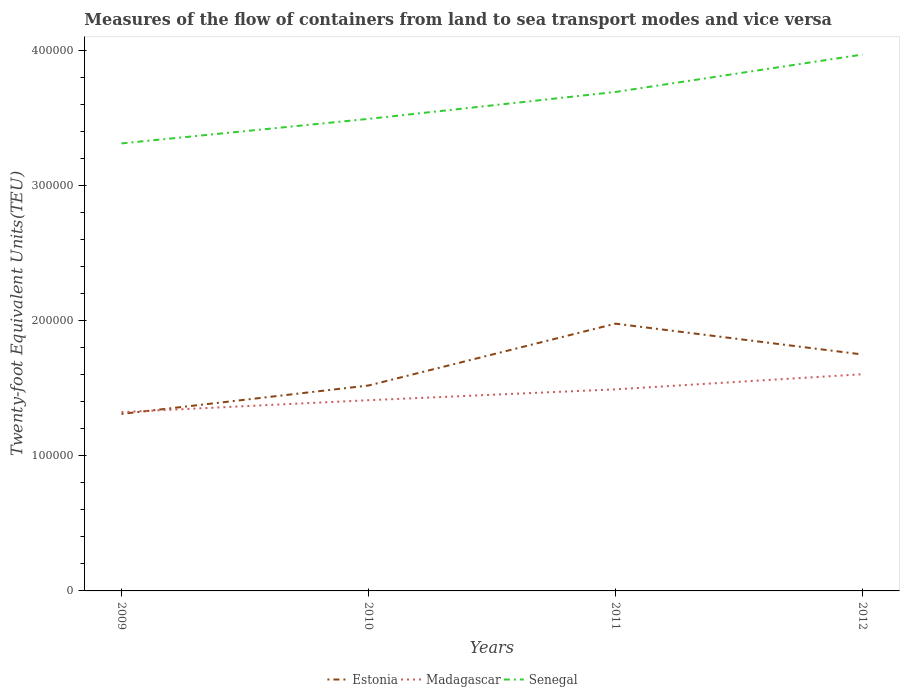Does the line corresponding to Estonia intersect with the line corresponding to Senegal?
Offer a terse response. No. Is the number of lines equal to the number of legend labels?
Provide a short and direct response. Yes. Across all years, what is the maximum container port traffic in Estonia?
Your answer should be compact. 1.31e+05. In which year was the container port traffic in Madagascar maximum?
Your response must be concise. 2009. What is the total container port traffic in Senegal in the graph?
Offer a very short reply. -1.99e+04. What is the difference between the highest and the second highest container port traffic in Madagascar?
Offer a very short reply. 2.80e+04. Is the container port traffic in Madagascar strictly greater than the container port traffic in Estonia over the years?
Offer a very short reply. No. How many years are there in the graph?
Your response must be concise. 4. What is the title of the graph?
Keep it short and to the point. Measures of the flow of containers from land to sea transport modes and vice versa. What is the label or title of the X-axis?
Your answer should be very brief. Years. What is the label or title of the Y-axis?
Give a very brief answer. Twenty-foot Equivalent Units(TEU). What is the Twenty-foot Equivalent Units(TEU) in Estonia in 2009?
Your response must be concise. 1.31e+05. What is the Twenty-foot Equivalent Units(TEU) of Madagascar in 2009?
Give a very brief answer. 1.32e+05. What is the Twenty-foot Equivalent Units(TEU) of Senegal in 2009?
Offer a very short reply. 3.31e+05. What is the Twenty-foot Equivalent Units(TEU) in Estonia in 2010?
Provide a succinct answer. 1.52e+05. What is the Twenty-foot Equivalent Units(TEU) in Madagascar in 2010?
Offer a terse response. 1.41e+05. What is the Twenty-foot Equivalent Units(TEU) in Senegal in 2010?
Give a very brief answer. 3.49e+05. What is the Twenty-foot Equivalent Units(TEU) of Estonia in 2011?
Offer a very short reply. 1.98e+05. What is the Twenty-foot Equivalent Units(TEU) in Madagascar in 2011?
Keep it short and to the point. 1.49e+05. What is the Twenty-foot Equivalent Units(TEU) in Senegal in 2011?
Ensure brevity in your answer.  3.69e+05. What is the Twenty-foot Equivalent Units(TEU) of Estonia in 2012?
Make the answer very short. 1.75e+05. What is the Twenty-foot Equivalent Units(TEU) in Madagascar in 2012?
Offer a terse response. 1.60e+05. What is the Twenty-foot Equivalent Units(TEU) of Senegal in 2012?
Your answer should be very brief. 3.97e+05. Across all years, what is the maximum Twenty-foot Equivalent Units(TEU) of Estonia?
Ensure brevity in your answer.  1.98e+05. Across all years, what is the maximum Twenty-foot Equivalent Units(TEU) in Madagascar?
Your response must be concise. 1.60e+05. Across all years, what is the maximum Twenty-foot Equivalent Units(TEU) in Senegal?
Offer a terse response. 3.97e+05. Across all years, what is the minimum Twenty-foot Equivalent Units(TEU) of Estonia?
Offer a terse response. 1.31e+05. Across all years, what is the minimum Twenty-foot Equivalent Units(TEU) in Madagascar?
Offer a terse response. 1.32e+05. Across all years, what is the minimum Twenty-foot Equivalent Units(TEU) of Senegal?
Provide a short and direct response. 3.31e+05. What is the total Twenty-foot Equivalent Units(TEU) of Estonia in the graph?
Offer a terse response. 6.56e+05. What is the total Twenty-foot Equivalent Units(TEU) of Madagascar in the graph?
Provide a short and direct response. 5.83e+05. What is the total Twenty-foot Equivalent Units(TEU) in Senegal in the graph?
Provide a short and direct response. 1.45e+06. What is the difference between the Twenty-foot Equivalent Units(TEU) in Estonia in 2009 and that in 2010?
Make the answer very short. -2.10e+04. What is the difference between the Twenty-foot Equivalent Units(TEU) in Madagascar in 2009 and that in 2010?
Ensure brevity in your answer.  -8815. What is the difference between the Twenty-foot Equivalent Units(TEU) in Senegal in 2009 and that in 2010?
Give a very brief answer. -1.82e+04. What is the difference between the Twenty-foot Equivalent Units(TEU) of Estonia in 2009 and that in 2011?
Offer a terse response. -6.68e+04. What is the difference between the Twenty-foot Equivalent Units(TEU) of Madagascar in 2009 and that in 2011?
Your answer should be very brief. -1.69e+04. What is the difference between the Twenty-foot Equivalent Units(TEU) of Senegal in 2009 and that in 2011?
Make the answer very short. -3.81e+04. What is the difference between the Twenty-foot Equivalent Units(TEU) of Estonia in 2009 and that in 2012?
Make the answer very short. -4.40e+04. What is the difference between the Twenty-foot Equivalent Units(TEU) in Madagascar in 2009 and that in 2012?
Your answer should be compact. -2.80e+04. What is the difference between the Twenty-foot Equivalent Units(TEU) of Senegal in 2009 and that in 2012?
Offer a terse response. -6.57e+04. What is the difference between the Twenty-foot Equivalent Units(TEU) of Estonia in 2010 and that in 2011?
Give a very brief answer. -4.57e+04. What is the difference between the Twenty-foot Equivalent Units(TEU) in Madagascar in 2010 and that in 2011?
Provide a short and direct response. -8042.3. What is the difference between the Twenty-foot Equivalent Units(TEU) of Senegal in 2010 and that in 2011?
Keep it short and to the point. -1.99e+04. What is the difference between the Twenty-foot Equivalent Units(TEU) of Estonia in 2010 and that in 2012?
Keep it short and to the point. -2.30e+04. What is the difference between the Twenty-foot Equivalent Units(TEU) in Madagascar in 2010 and that in 2012?
Ensure brevity in your answer.  -1.92e+04. What is the difference between the Twenty-foot Equivalent Units(TEU) in Senegal in 2010 and that in 2012?
Your answer should be very brief. -4.76e+04. What is the difference between the Twenty-foot Equivalent Units(TEU) of Estonia in 2011 and that in 2012?
Your response must be concise. 2.28e+04. What is the difference between the Twenty-foot Equivalent Units(TEU) of Madagascar in 2011 and that in 2012?
Provide a short and direct response. -1.12e+04. What is the difference between the Twenty-foot Equivalent Units(TEU) of Senegal in 2011 and that in 2012?
Make the answer very short. -2.77e+04. What is the difference between the Twenty-foot Equivalent Units(TEU) of Estonia in 2009 and the Twenty-foot Equivalent Units(TEU) of Madagascar in 2010?
Offer a very short reply. -1.02e+04. What is the difference between the Twenty-foot Equivalent Units(TEU) in Estonia in 2009 and the Twenty-foot Equivalent Units(TEU) in Senegal in 2010?
Give a very brief answer. -2.18e+05. What is the difference between the Twenty-foot Equivalent Units(TEU) of Madagascar in 2009 and the Twenty-foot Equivalent Units(TEU) of Senegal in 2010?
Make the answer very short. -2.17e+05. What is the difference between the Twenty-foot Equivalent Units(TEU) of Estonia in 2009 and the Twenty-foot Equivalent Units(TEU) of Madagascar in 2011?
Ensure brevity in your answer.  -1.82e+04. What is the difference between the Twenty-foot Equivalent Units(TEU) in Estonia in 2009 and the Twenty-foot Equivalent Units(TEU) in Senegal in 2011?
Provide a succinct answer. -2.38e+05. What is the difference between the Twenty-foot Equivalent Units(TEU) of Madagascar in 2009 and the Twenty-foot Equivalent Units(TEU) of Senegal in 2011?
Your answer should be compact. -2.37e+05. What is the difference between the Twenty-foot Equivalent Units(TEU) of Estonia in 2009 and the Twenty-foot Equivalent Units(TEU) of Madagascar in 2012?
Your answer should be compact. -2.94e+04. What is the difference between the Twenty-foot Equivalent Units(TEU) in Estonia in 2009 and the Twenty-foot Equivalent Units(TEU) in Senegal in 2012?
Offer a very short reply. -2.66e+05. What is the difference between the Twenty-foot Equivalent Units(TEU) of Madagascar in 2009 and the Twenty-foot Equivalent Units(TEU) of Senegal in 2012?
Offer a terse response. -2.65e+05. What is the difference between the Twenty-foot Equivalent Units(TEU) of Estonia in 2010 and the Twenty-foot Equivalent Units(TEU) of Madagascar in 2011?
Make the answer very short. 2833.7. What is the difference between the Twenty-foot Equivalent Units(TEU) of Estonia in 2010 and the Twenty-foot Equivalent Units(TEU) of Senegal in 2011?
Make the answer very short. -2.17e+05. What is the difference between the Twenty-foot Equivalent Units(TEU) of Madagascar in 2010 and the Twenty-foot Equivalent Units(TEU) of Senegal in 2011?
Make the answer very short. -2.28e+05. What is the difference between the Twenty-foot Equivalent Units(TEU) in Estonia in 2010 and the Twenty-foot Equivalent Units(TEU) in Madagascar in 2012?
Provide a short and direct response. -8351.45. What is the difference between the Twenty-foot Equivalent Units(TEU) of Estonia in 2010 and the Twenty-foot Equivalent Units(TEU) of Senegal in 2012?
Offer a very short reply. -2.45e+05. What is the difference between the Twenty-foot Equivalent Units(TEU) of Madagascar in 2010 and the Twenty-foot Equivalent Units(TEU) of Senegal in 2012?
Ensure brevity in your answer.  -2.56e+05. What is the difference between the Twenty-foot Equivalent Units(TEU) of Estonia in 2011 and the Twenty-foot Equivalent Units(TEU) of Madagascar in 2012?
Provide a succinct answer. 3.74e+04. What is the difference between the Twenty-foot Equivalent Units(TEU) in Estonia in 2011 and the Twenty-foot Equivalent Units(TEU) in Senegal in 2012?
Your answer should be very brief. -1.99e+05. What is the difference between the Twenty-foot Equivalent Units(TEU) of Madagascar in 2011 and the Twenty-foot Equivalent Units(TEU) of Senegal in 2012?
Give a very brief answer. -2.48e+05. What is the average Twenty-foot Equivalent Units(TEU) in Estonia per year?
Offer a very short reply. 1.64e+05. What is the average Twenty-foot Equivalent Units(TEU) in Madagascar per year?
Your answer should be very brief. 1.46e+05. What is the average Twenty-foot Equivalent Units(TEU) of Senegal per year?
Give a very brief answer. 3.62e+05. In the year 2009, what is the difference between the Twenty-foot Equivalent Units(TEU) of Estonia and Twenty-foot Equivalent Units(TEU) of Madagascar?
Give a very brief answer. -1339. In the year 2009, what is the difference between the Twenty-foot Equivalent Units(TEU) of Estonia and Twenty-foot Equivalent Units(TEU) of Senegal?
Provide a short and direct response. -2.00e+05. In the year 2009, what is the difference between the Twenty-foot Equivalent Units(TEU) in Madagascar and Twenty-foot Equivalent Units(TEU) in Senegal?
Your answer should be compact. -1.99e+05. In the year 2010, what is the difference between the Twenty-foot Equivalent Units(TEU) of Estonia and Twenty-foot Equivalent Units(TEU) of Madagascar?
Your response must be concise. 1.09e+04. In the year 2010, what is the difference between the Twenty-foot Equivalent Units(TEU) in Estonia and Twenty-foot Equivalent Units(TEU) in Senegal?
Ensure brevity in your answer.  -1.97e+05. In the year 2010, what is the difference between the Twenty-foot Equivalent Units(TEU) in Madagascar and Twenty-foot Equivalent Units(TEU) in Senegal?
Offer a terse response. -2.08e+05. In the year 2011, what is the difference between the Twenty-foot Equivalent Units(TEU) in Estonia and Twenty-foot Equivalent Units(TEU) in Madagascar?
Ensure brevity in your answer.  4.86e+04. In the year 2011, what is the difference between the Twenty-foot Equivalent Units(TEU) of Estonia and Twenty-foot Equivalent Units(TEU) of Senegal?
Provide a short and direct response. -1.71e+05. In the year 2011, what is the difference between the Twenty-foot Equivalent Units(TEU) of Madagascar and Twenty-foot Equivalent Units(TEU) of Senegal?
Make the answer very short. -2.20e+05. In the year 2012, what is the difference between the Twenty-foot Equivalent Units(TEU) of Estonia and Twenty-foot Equivalent Units(TEU) of Madagascar?
Your answer should be very brief. 1.46e+04. In the year 2012, what is the difference between the Twenty-foot Equivalent Units(TEU) of Estonia and Twenty-foot Equivalent Units(TEU) of Senegal?
Keep it short and to the point. -2.22e+05. In the year 2012, what is the difference between the Twenty-foot Equivalent Units(TEU) of Madagascar and Twenty-foot Equivalent Units(TEU) of Senegal?
Your answer should be compact. -2.37e+05. What is the ratio of the Twenty-foot Equivalent Units(TEU) in Estonia in 2009 to that in 2010?
Your answer should be very brief. 0.86. What is the ratio of the Twenty-foot Equivalent Units(TEU) of Madagascar in 2009 to that in 2010?
Offer a terse response. 0.94. What is the ratio of the Twenty-foot Equivalent Units(TEU) of Senegal in 2009 to that in 2010?
Provide a short and direct response. 0.95. What is the ratio of the Twenty-foot Equivalent Units(TEU) in Estonia in 2009 to that in 2011?
Provide a short and direct response. 0.66. What is the ratio of the Twenty-foot Equivalent Units(TEU) in Madagascar in 2009 to that in 2011?
Ensure brevity in your answer.  0.89. What is the ratio of the Twenty-foot Equivalent Units(TEU) of Senegal in 2009 to that in 2011?
Keep it short and to the point. 0.9. What is the ratio of the Twenty-foot Equivalent Units(TEU) of Estonia in 2009 to that in 2012?
Offer a very short reply. 0.75. What is the ratio of the Twenty-foot Equivalent Units(TEU) in Madagascar in 2009 to that in 2012?
Provide a short and direct response. 0.83. What is the ratio of the Twenty-foot Equivalent Units(TEU) in Senegal in 2009 to that in 2012?
Keep it short and to the point. 0.83. What is the ratio of the Twenty-foot Equivalent Units(TEU) of Estonia in 2010 to that in 2011?
Your response must be concise. 0.77. What is the ratio of the Twenty-foot Equivalent Units(TEU) in Madagascar in 2010 to that in 2011?
Your answer should be very brief. 0.95. What is the ratio of the Twenty-foot Equivalent Units(TEU) of Senegal in 2010 to that in 2011?
Ensure brevity in your answer.  0.95. What is the ratio of the Twenty-foot Equivalent Units(TEU) of Estonia in 2010 to that in 2012?
Provide a short and direct response. 0.87. What is the ratio of the Twenty-foot Equivalent Units(TEU) in Madagascar in 2010 to that in 2012?
Give a very brief answer. 0.88. What is the ratio of the Twenty-foot Equivalent Units(TEU) of Senegal in 2010 to that in 2012?
Your answer should be compact. 0.88. What is the ratio of the Twenty-foot Equivalent Units(TEU) in Estonia in 2011 to that in 2012?
Offer a terse response. 1.13. What is the ratio of the Twenty-foot Equivalent Units(TEU) in Madagascar in 2011 to that in 2012?
Your answer should be very brief. 0.93. What is the ratio of the Twenty-foot Equivalent Units(TEU) in Senegal in 2011 to that in 2012?
Your response must be concise. 0.93. What is the difference between the highest and the second highest Twenty-foot Equivalent Units(TEU) of Estonia?
Provide a short and direct response. 2.28e+04. What is the difference between the highest and the second highest Twenty-foot Equivalent Units(TEU) of Madagascar?
Your answer should be compact. 1.12e+04. What is the difference between the highest and the second highest Twenty-foot Equivalent Units(TEU) of Senegal?
Ensure brevity in your answer.  2.77e+04. What is the difference between the highest and the lowest Twenty-foot Equivalent Units(TEU) of Estonia?
Your answer should be very brief. 6.68e+04. What is the difference between the highest and the lowest Twenty-foot Equivalent Units(TEU) in Madagascar?
Ensure brevity in your answer.  2.80e+04. What is the difference between the highest and the lowest Twenty-foot Equivalent Units(TEU) in Senegal?
Provide a short and direct response. 6.57e+04. 